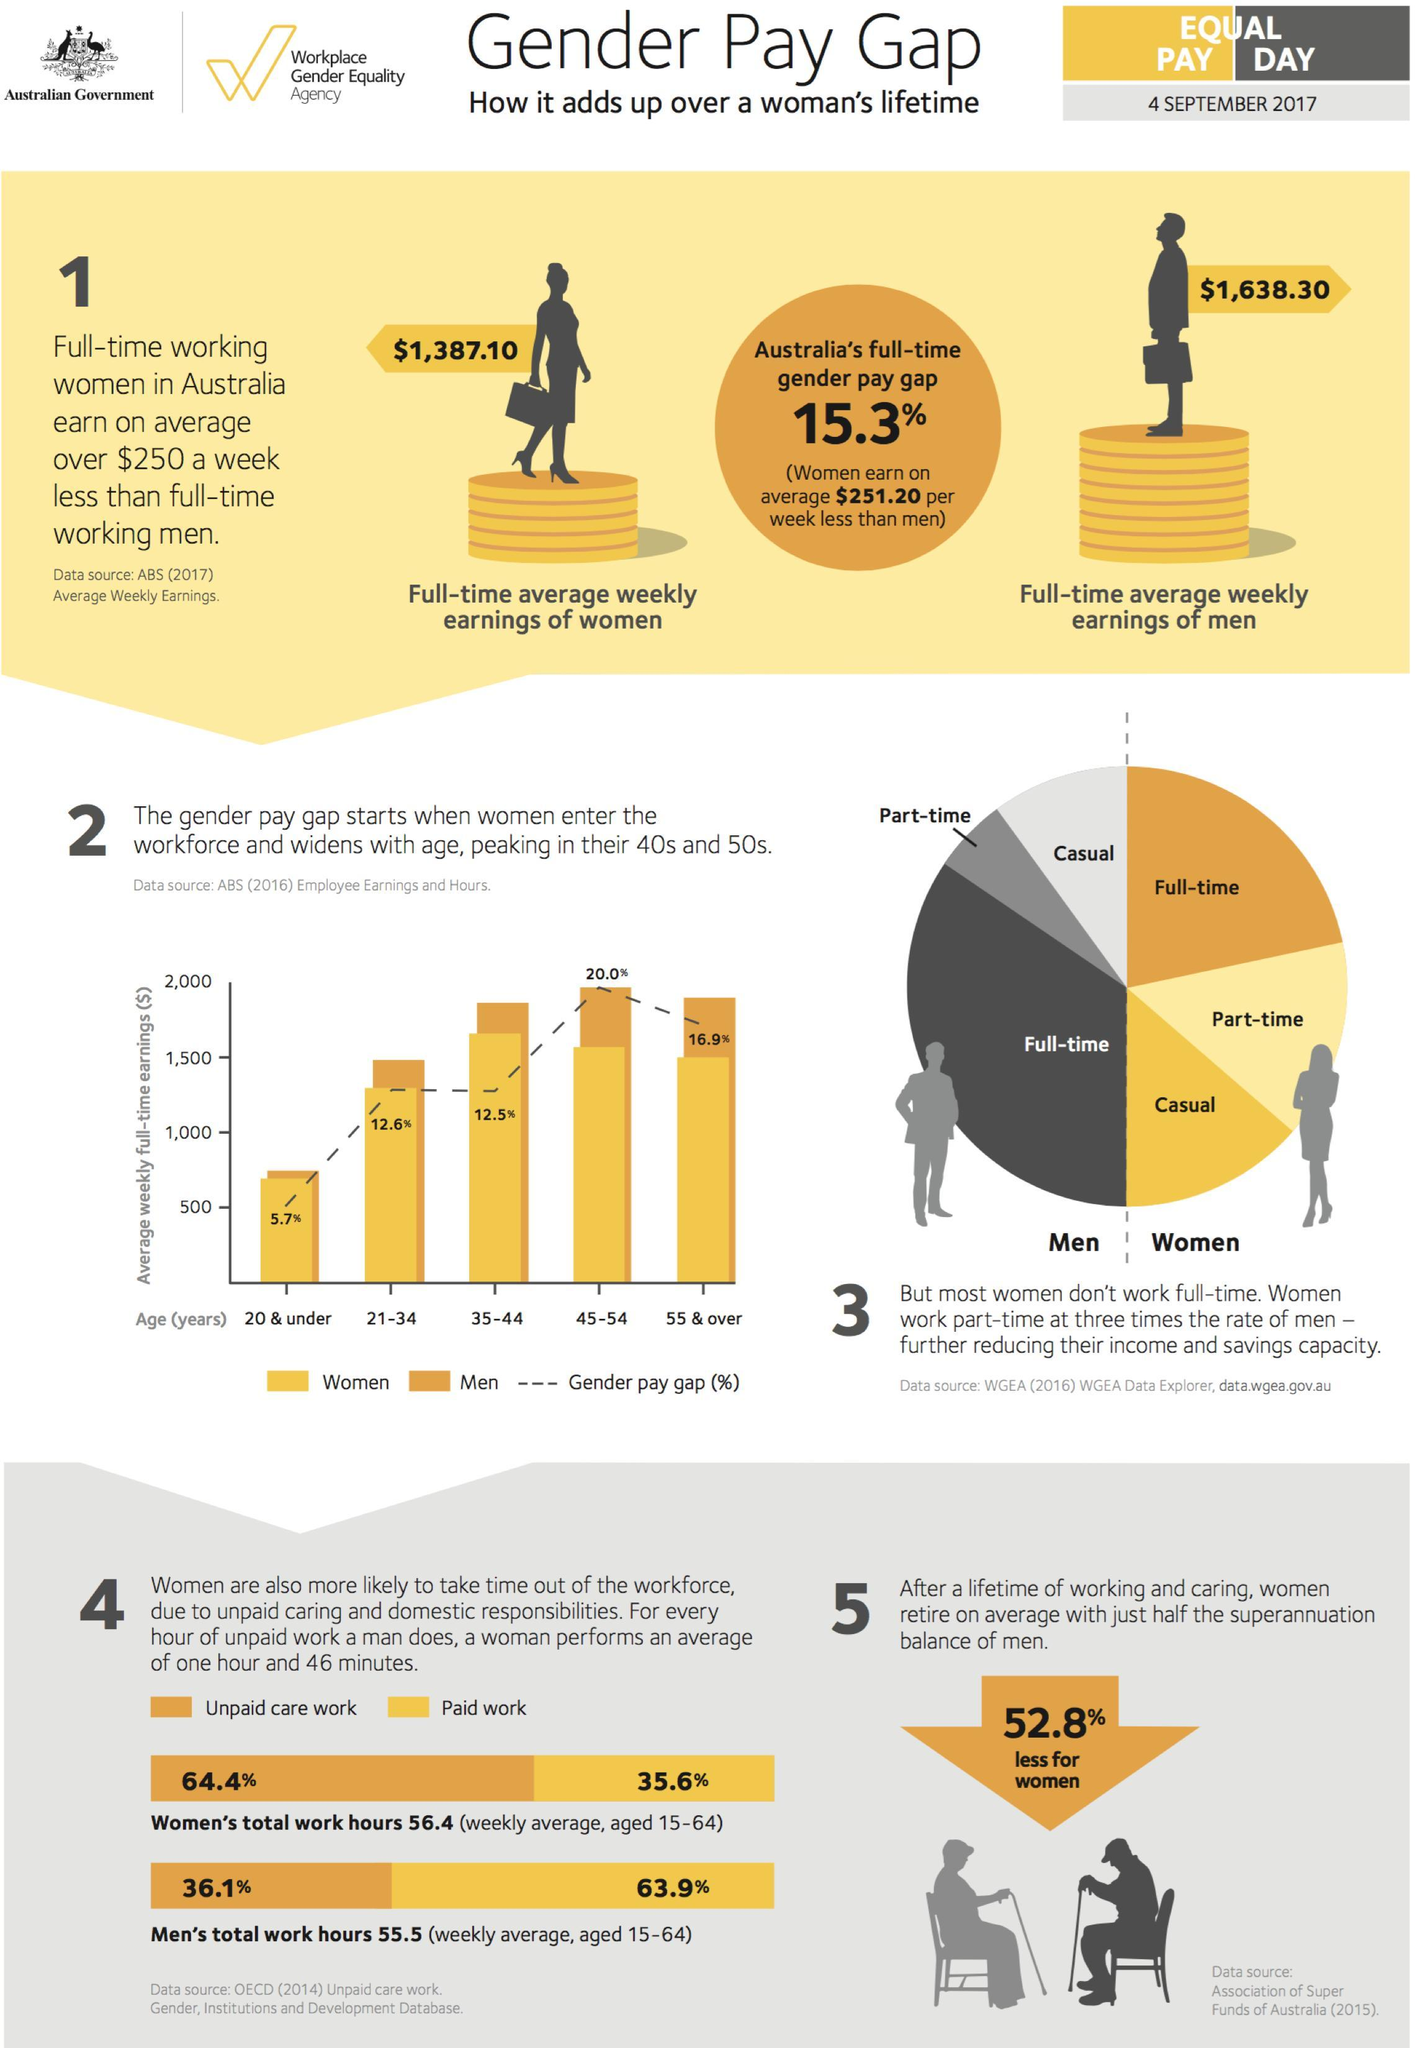What percentage of paid work is done by women aged 15-64 in Australia as of 4 September 2017?
Answer the question with a short phrase. 35.6% What is the gender pay gap percentage of 45-54 age group in Australia as of 4 September 2017? 20.0% What is the full-time average weekly earnings of women in Australia as of 4 September 2017? $1,387.10 What percentage of unpaid care work is done by women aged 15-64 in Australia as of 4 September 2017? 64.4% What is the gender pay gap percentage of 55+ year age in Australia as of 4 September 2017? 16.9% What percentage of paid work is done by men aged 15-64 in Australia as of 4 September 2017? 63.9% Which age group has highest gender pay gap percentage in Australia as of 4 September 2017? 45-54 Which age group has least gender pay gap percentage in Australia as of 4 September 2017? 20 & under What percentage of unpaid care work is done by men aged 15-64 in Australia as of 4 September 2017? 36.1% What is the full-time average weekly earnings of men in Australia as of 4 September 2017? $1,638.30 